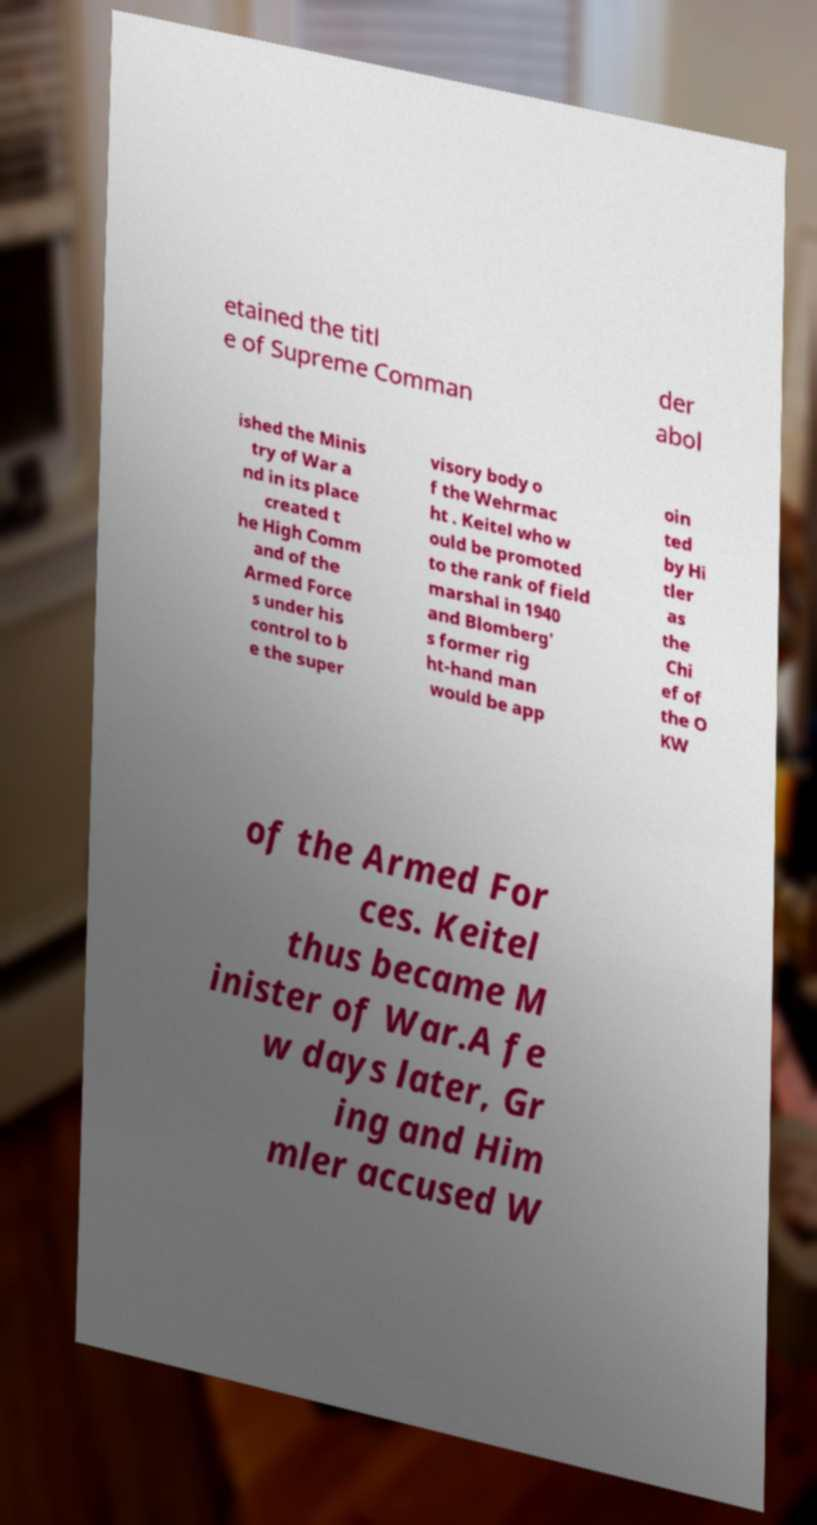Can you accurately transcribe the text from the provided image for me? etained the titl e of Supreme Comman der abol ished the Minis try of War a nd in its place created t he High Comm and of the Armed Force s under his control to b e the super visory body o f the Wehrmac ht . Keitel who w ould be promoted to the rank of field marshal in 1940 and Blomberg' s former rig ht-hand man would be app oin ted by Hi tler as the Chi ef of the O KW of the Armed For ces. Keitel thus became M inister of War.A fe w days later, Gr ing and Him mler accused W 